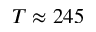Convert formula to latex. <formula><loc_0><loc_0><loc_500><loc_500>T \approx 2 4 5</formula> 